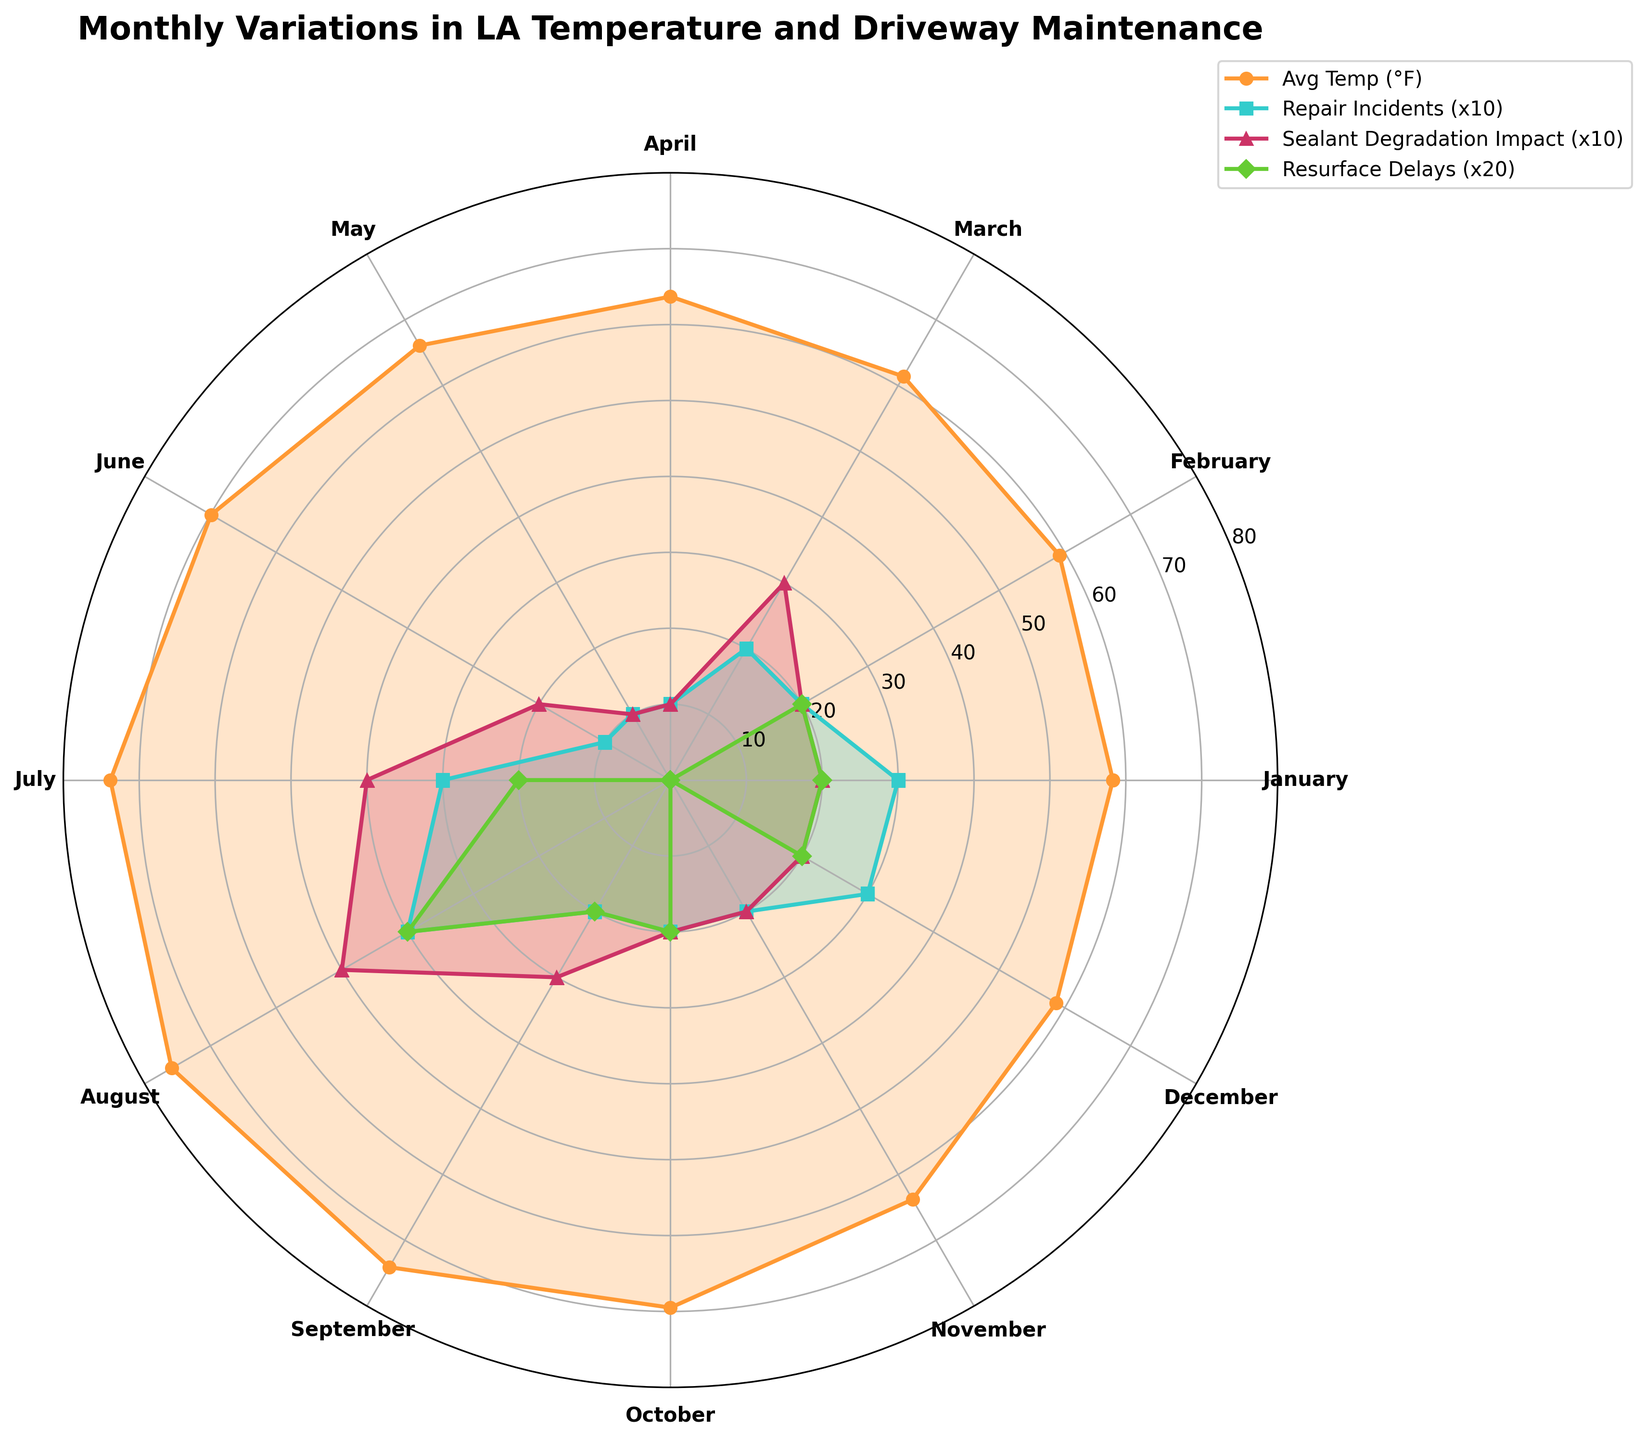What's the title of the plot? The title of the plot is prominently displayed at the top and reads "Monthly Variations in LA Temperature and Driveway Maintenance".
Answer: Monthly Variations in LA Temperature and Driveway Maintenance What color represents the "Avg Temp (°F)" in the plot? The plot uses different colors for each dataset, and the "Avg Temp (°F)" is represented by an orange color.
Answer: Orange Which month has the highest average temperature? By examining the plot, you can see that the month with the highest average temperature is the one where the orange line reaches its peak. This peak occurs in August.
Answer: August How many repair incidents occurred in July? The plot includes repair incidents data represented by the blue line. To find the number of incidents in July, look for the blue line's value at the position corresponding to July, which shows 3 incidents.
Answer: 3 During which month did resurface delays have the highest impact? The green line in the plot represents resurface delays. You can see the tallest green peak corresponds to August, indicating the highest impact during this month.
Answer: August Which dataset has the lowest value in April? The plot shows all datasets' values for various months. In April, look for the smallest peak or lowest point among the colored lines. The yellow-green line for "Resurface Delays" shows a value of 0 in April.
Answer: Resurface Delays Compare the sealant degradation impact in July and August. Which month had a higher impact? The purple line in the plot represents sealant degradation impact. By comparing the height of the peaks corresponding to July and August, you can see that August had a higher impact than July.
Answer: August What is the average number of repair incidents across all months? To find the average, sum up the number of repair incidents for all months: (3 + 2 + 2 + 1 + 1 + 1 + 3 + 4 + 2 + 2 + 2 + 3 = 26) and divide by the total number of months, which is 12. The average is 26/12 = 2.17, rounded to two decimal places.
Answer: 2.17 In which months does the temperature exceed 70°F? The orange line indicates the average temperatures. By locating the points where the line exceeds the 70°F mark, you can see that temperatures exceed 70°F in July and August.
Answer: July and August What is the difference in the resurface delays between January and August? The green line indicates resurface delays. The plot shows that the value in January is 1, and the value in August is 2. The difference is calculated as 2 - 1 = 1.
Answer: 1 